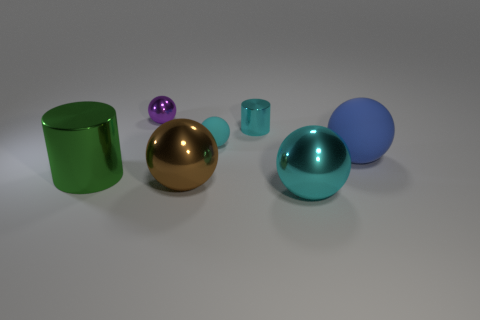Subtract 2 balls. How many balls are left? 3 Subtract all gray spheres. Subtract all cyan cubes. How many spheres are left? 5 Add 3 tiny purple things. How many objects exist? 10 Subtract all cylinders. How many objects are left? 5 Add 6 cyan things. How many cyan things are left? 9 Add 6 small yellow metallic balls. How many small yellow metallic balls exist? 6 Subtract 1 cyan spheres. How many objects are left? 6 Subtract all tiny yellow metallic cylinders. Subtract all big cylinders. How many objects are left? 6 